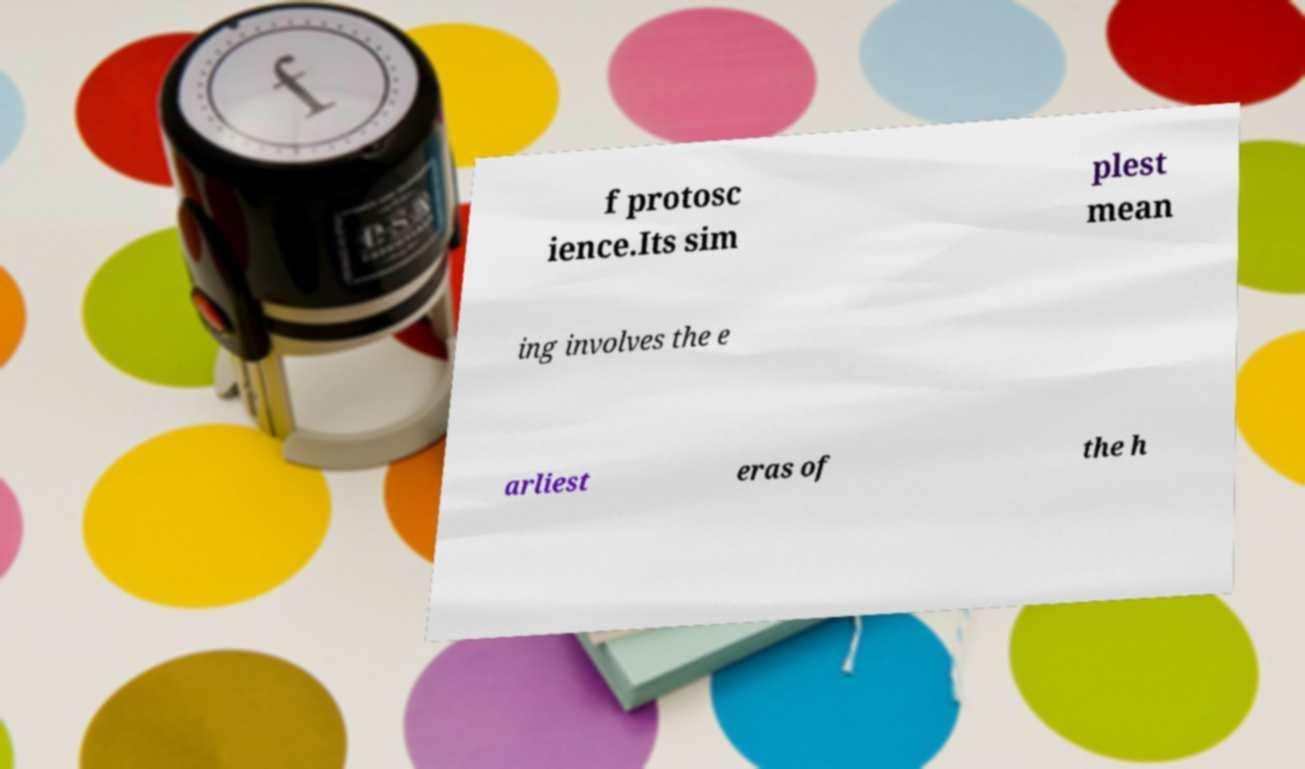Please identify and transcribe the text found in this image. f protosc ience.Its sim plest mean ing involves the e arliest eras of the h 